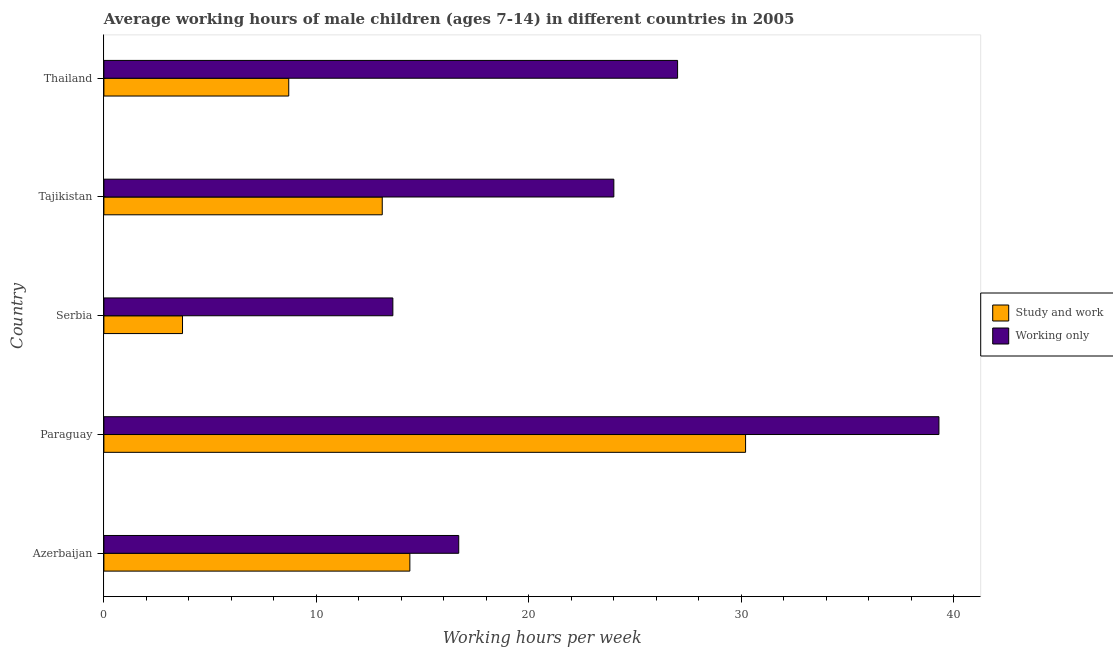How many groups of bars are there?
Your response must be concise. 5. Are the number of bars per tick equal to the number of legend labels?
Ensure brevity in your answer.  Yes. Are the number of bars on each tick of the Y-axis equal?
Provide a succinct answer. Yes. How many bars are there on the 1st tick from the bottom?
Make the answer very short. 2. What is the label of the 5th group of bars from the top?
Give a very brief answer. Azerbaijan. In how many cases, is the number of bars for a given country not equal to the number of legend labels?
Ensure brevity in your answer.  0. What is the average working hour of children involved in only work in Paraguay?
Ensure brevity in your answer.  39.3. Across all countries, what is the maximum average working hour of children involved in only work?
Provide a short and direct response. 39.3. In which country was the average working hour of children involved in study and work maximum?
Offer a very short reply. Paraguay. In which country was the average working hour of children involved in only work minimum?
Provide a short and direct response. Serbia. What is the total average working hour of children involved in study and work in the graph?
Offer a terse response. 70.1. What is the difference between the average working hour of children involved in only work in Paraguay and the average working hour of children involved in study and work in Azerbaijan?
Keep it short and to the point. 24.9. What is the average average working hour of children involved in study and work per country?
Provide a succinct answer. 14.02. In how many countries, is the average working hour of children involved in study and work greater than 30 hours?
Provide a succinct answer. 1. What is the ratio of the average working hour of children involved in only work in Azerbaijan to that in Thailand?
Make the answer very short. 0.62. What is the difference between the highest and the second highest average working hour of children involved in only work?
Ensure brevity in your answer.  12.3. What is the difference between the highest and the lowest average working hour of children involved in only work?
Your answer should be very brief. 25.7. What does the 1st bar from the top in Paraguay represents?
Give a very brief answer. Working only. What does the 2nd bar from the bottom in Thailand represents?
Your answer should be compact. Working only. How many bars are there?
Provide a short and direct response. 10. Are all the bars in the graph horizontal?
Your answer should be compact. Yes. What is the difference between two consecutive major ticks on the X-axis?
Your answer should be very brief. 10. Are the values on the major ticks of X-axis written in scientific E-notation?
Give a very brief answer. No. Does the graph contain any zero values?
Provide a short and direct response. No. How many legend labels are there?
Your answer should be very brief. 2. How are the legend labels stacked?
Your answer should be compact. Vertical. What is the title of the graph?
Ensure brevity in your answer.  Average working hours of male children (ages 7-14) in different countries in 2005. What is the label or title of the X-axis?
Give a very brief answer. Working hours per week. What is the Working hours per week of Study and work in Paraguay?
Make the answer very short. 30.2. What is the Working hours per week in Working only in Paraguay?
Provide a short and direct response. 39.3. What is the Working hours per week in Study and work in Serbia?
Your response must be concise. 3.7. What is the Working hours per week in Working only in Serbia?
Make the answer very short. 13.6. What is the Working hours per week of Working only in Tajikistan?
Your answer should be compact. 24. What is the Working hours per week in Working only in Thailand?
Provide a succinct answer. 27. Across all countries, what is the maximum Working hours per week in Study and work?
Your answer should be very brief. 30.2. Across all countries, what is the maximum Working hours per week of Working only?
Give a very brief answer. 39.3. Across all countries, what is the minimum Working hours per week in Study and work?
Provide a succinct answer. 3.7. Across all countries, what is the minimum Working hours per week of Working only?
Your answer should be very brief. 13.6. What is the total Working hours per week of Study and work in the graph?
Provide a succinct answer. 70.1. What is the total Working hours per week in Working only in the graph?
Offer a very short reply. 120.6. What is the difference between the Working hours per week in Study and work in Azerbaijan and that in Paraguay?
Ensure brevity in your answer.  -15.8. What is the difference between the Working hours per week of Working only in Azerbaijan and that in Paraguay?
Keep it short and to the point. -22.6. What is the difference between the Working hours per week in Study and work in Azerbaijan and that in Serbia?
Offer a very short reply. 10.7. What is the difference between the Working hours per week in Working only in Azerbaijan and that in Serbia?
Give a very brief answer. 3.1. What is the difference between the Working hours per week in Study and work in Azerbaijan and that in Tajikistan?
Your answer should be very brief. 1.3. What is the difference between the Working hours per week in Working only in Azerbaijan and that in Thailand?
Offer a terse response. -10.3. What is the difference between the Working hours per week in Study and work in Paraguay and that in Serbia?
Provide a succinct answer. 26.5. What is the difference between the Working hours per week of Working only in Paraguay and that in Serbia?
Your response must be concise. 25.7. What is the difference between the Working hours per week of Study and work in Paraguay and that in Tajikistan?
Ensure brevity in your answer.  17.1. What is the difference between the Working hours per week in Working only in Paraguay and that in Tajikistan?
Your response must be concise. 15.3. What is the difference between the Working hours per week of Study and work in Azerbaijan and the Working hours per week of Working only in Paraguay?
Your response must be concise. -24.9. What is the difference between the Working hours per week in Study and work in Azerbaijan and the Working hours per week in Working only in Tajikistan?
Offer a terse response. -9.6. What is the difference between the Working hours per week in Study and work in Paraguay and the Working hours per week in Working only in Serbia?
Give a very brief answer. 16.6. What is the difference between the Working hours per week in Study and work in Paraguay and the Working hours per week in Working only in Tajikistan?
Provide a succinct answer. 6.2. What is the difference between the Working hours per week of Study and work in Paraguay and the Working hours per week of Working only in Thailand?
Provide a succinct answer. 3.2. What is the difference between the Working hours per week of Study and work in Serbia and the Working hours per week of Working only in Tajikistan?
Your answer should be very brief. -20.3. What is the difference between the Working hours per week in Study and work in Serbia and the Working hours per week in Working only in Thailand?
Your answer should be compact. -23.3. What is the difference between the Working hours per week in Study and work in Tajikistan and the Working hours per week in Working only in Thailand?
Offer a very short reply. -13.9. What is the average Working hours per week in Study and work per country?
Your answer should be compact. 14.02. What is the average Working hours per week of Working only per country?
Ensure brevity in your answer.  24.12. What is the difference between the Working hours per week of Study and work and Working hours per week of Working only in Azerbaijan?
Provide a short and direct response. -2.3. What is the difference between the Working hours per week of Study and work and Working hours per week of Working only in Serbia?
Ensure brevity in your answer.  -9.9. What is the difference between the Working hours per week of Study and work and Working hours per week of Working only in Tajikistan?
Offer a terse response. -10.9. What is the difference between the Working hours per week in Study and work and Working hours per week in Working only in Thailand?
Give a very brief answer. -18.3. What is the ratio of the Working hours per week in Study and work in Azerbaijan to that in Paraguay?
Your response must be concise. 0.48. What is the ratio of the Working hours per week of Working only in Azerbaijan to that in Paraguay?
Make the answer very short. 0.42. What is the ratio of the Working hours per week in Study and work in Azerbaijan to that in Serbia?
Offer a terse response. 3.89. What is the ratio of the Working hours per week in Working only in Azerbaijan to that in Serbia?
Ensure brevity in your answer.  1.23. What is the ratio of the Working hours per week in Study and work in Azerbaijan to that in Tajikistan?
Ensure brevity in your answer.  1.1. What is the ratio of the Working hours per week of Working only in Azerbaijan to that in Tajikistan?
Keep it short and to the point. 0.7. What is the ratio of the Working hours per week of Study and work in Azerbaijan to that in Thailand?
Your answer should be compact. 1.66. What is the ratio of the Working hours per week in Working only in Azerbaijan to that in Thailand?
Provide a succinct answer. 0.62. What is the ratio of the Working hours per week of Study and work in Paraguay to that in Serbia?
Provide a succinct answer. 8.16. What is the ratio of the Working hours per week of Working only in Paraguay to that in Serbia?
Ensure brevity in your answer.  2.89. What is the ratio of the Working hours per week in Study and work in Paraguay to that in Tajikistan?
Your answer should be very brief. 2.31. What is the ratio of the Working hours per week of Working only in Paraguay to that in Tajikistan?
Provide a short and direct response. 1.64. What is the ratio of the Working hours per week of Study and work in Paraguay to that in Thailand?
Your answer should be compact. 3.47. What is the ratio of the Working hours per week of Working only in Paraguay to that in Thailand?
Offer a very short reply. 1.46. What is the ratio of the Working hours per week in Study and work in Serbia to that in Tajikistan?
Give a very brief answer. 0.28. What is the ratio of the Working hours per week of Working only in Serbia to that in Tajikistan?
Provide a succinct answer. 0.57. What is the ratio of the Working hours per week of Study and work in Serbia to that in Thailand?
Provide a short and direct response. 0.43. What is the ratio of the Working hours per week in Working only in Serbia to that in Thailand?
Give a very brief answer. 0.5. What is the ratio of the Working hours per week of Study and work in Tajikistan to that in Thailand?
Provide a short and direct response. 1.51. What is the ratio of the Working hours per week of Working only in Tajikistan to that in Thailand?
Offer a very short reply. 0.89. What is the difference between the highest and the lowest Working hours per week in Study and work?
Your answer should be very brief. 26.5. What is the difference between the highest and the lowest Working hours per week of Working only?
Your response must be concise. 25.7. 